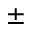<formula> <loc_0><loc_0><loc_500><loc_500>\pm</formula> 